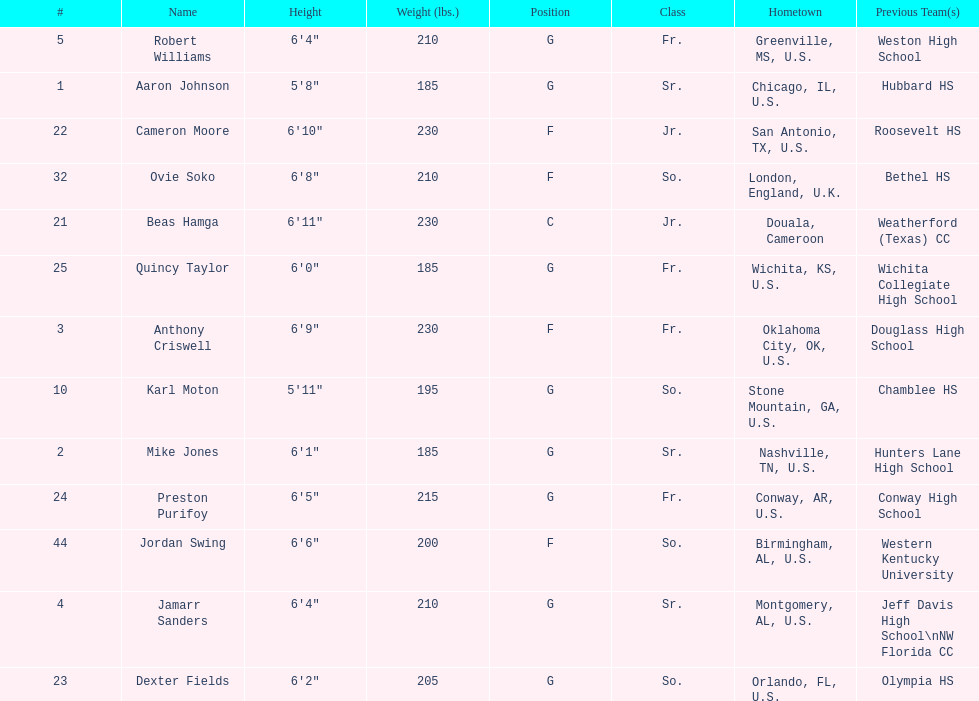Who is first on the roster? Aaron Johnson. 